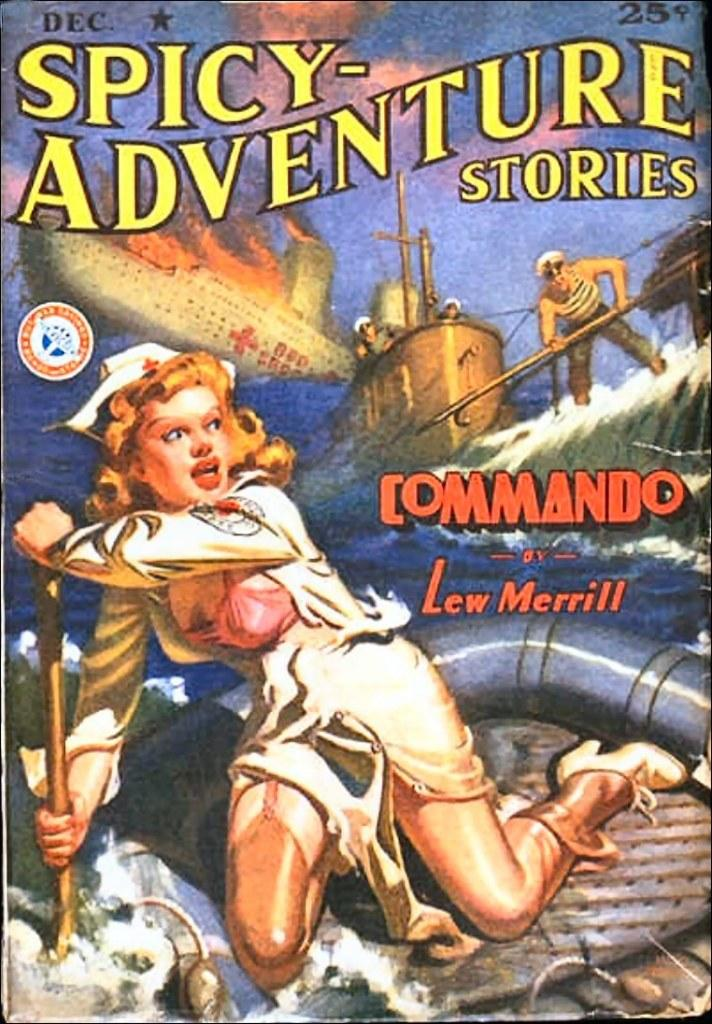<image>
Describe the image concisely. a comic that has spicy adventure stories written in it 